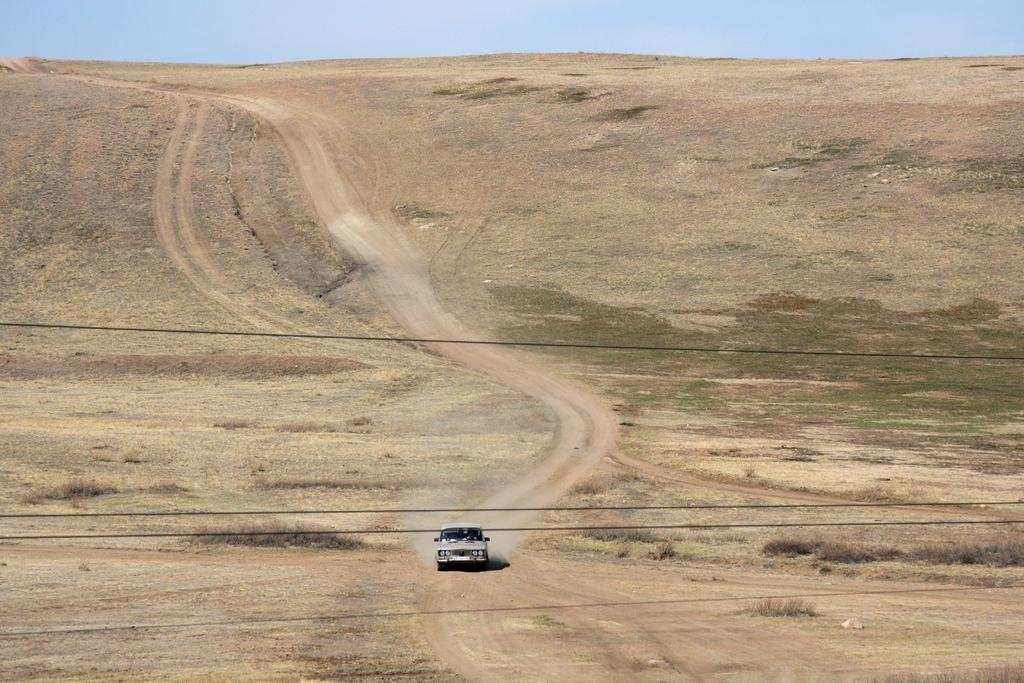What is located on the ground in the image? There is a vehicle on the ground in the image. What else can be seen in the image besides the vehicle? There are wires visible in the image, as well as grass. What is visible in the background of the image? The sky is visible in the background of the image. Can you see a gate in the image? There is no gate present in the image. Is there an island visible in the image? There is no island present in the image. 